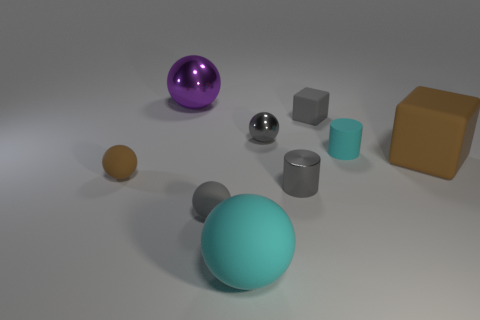Subtract all big purple metallic spheres. How many spheres are left? 4 Add 1 big gray cubes. How many objects exist? 10 Subtract all gray cylinders. How many cylinders are left? 1 Subtract all spheres. How many objects are left? 4 Subtract 3 balls. How many balls are left? 2 Subtract all gray cubes. Subtract all red cylinders. How many cubes are left? 1 Subtract all cyan blocks. How many gray balls are left? 2 Subtract all large cyan shiny objects. Subtract all gray objects. How many objects are left? 5 Add 8 shiny spheres. How many shiny spheres are left? 10 Add 6 brown rubber blocks. How many brown rubber blocks exist? 7 